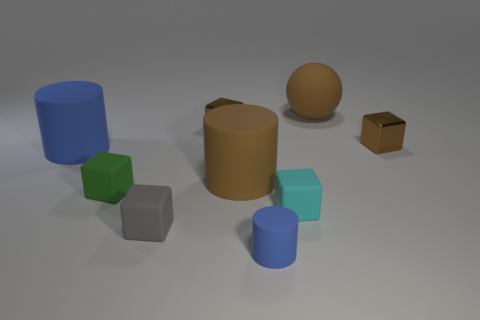Subtract all small cyan blocks. How many blocks are left? 4 Subtract all green blocks. How many blue cylinders are left? 2 Subtract 1 spheres. How many spheres are left? 0 Subtract all gray cubes. How many cubes are left? 4 Subtract all spheres. How many objects are left? 8 Add 8 gray matte things. How many gray matte things are left? 9 Add 7 large brown things. How many large brown things exist? 9 Subtract 1 cyan blocks. How many objects are left? 8 Subtract all yellow cubes. Subtract all green cylinders. How many cubes are left? 5 Subtract all blue things. Subtract all cyan matte spheres. How many objects are left? 7 